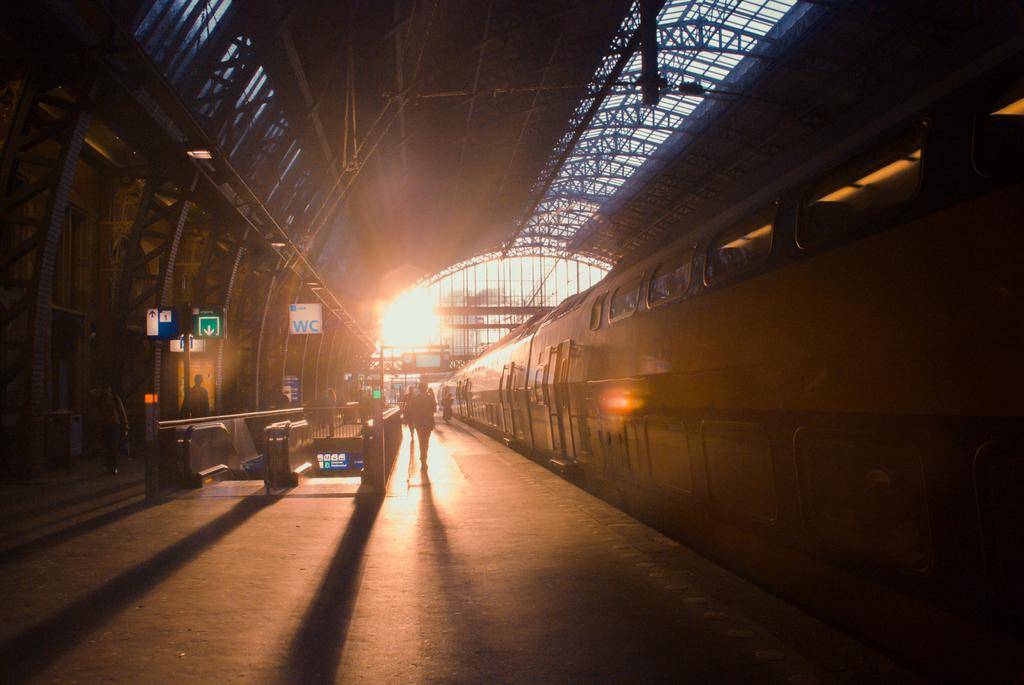<image>
Share a concise interpretation of the image provided. The train station has a white sign that says WC. 